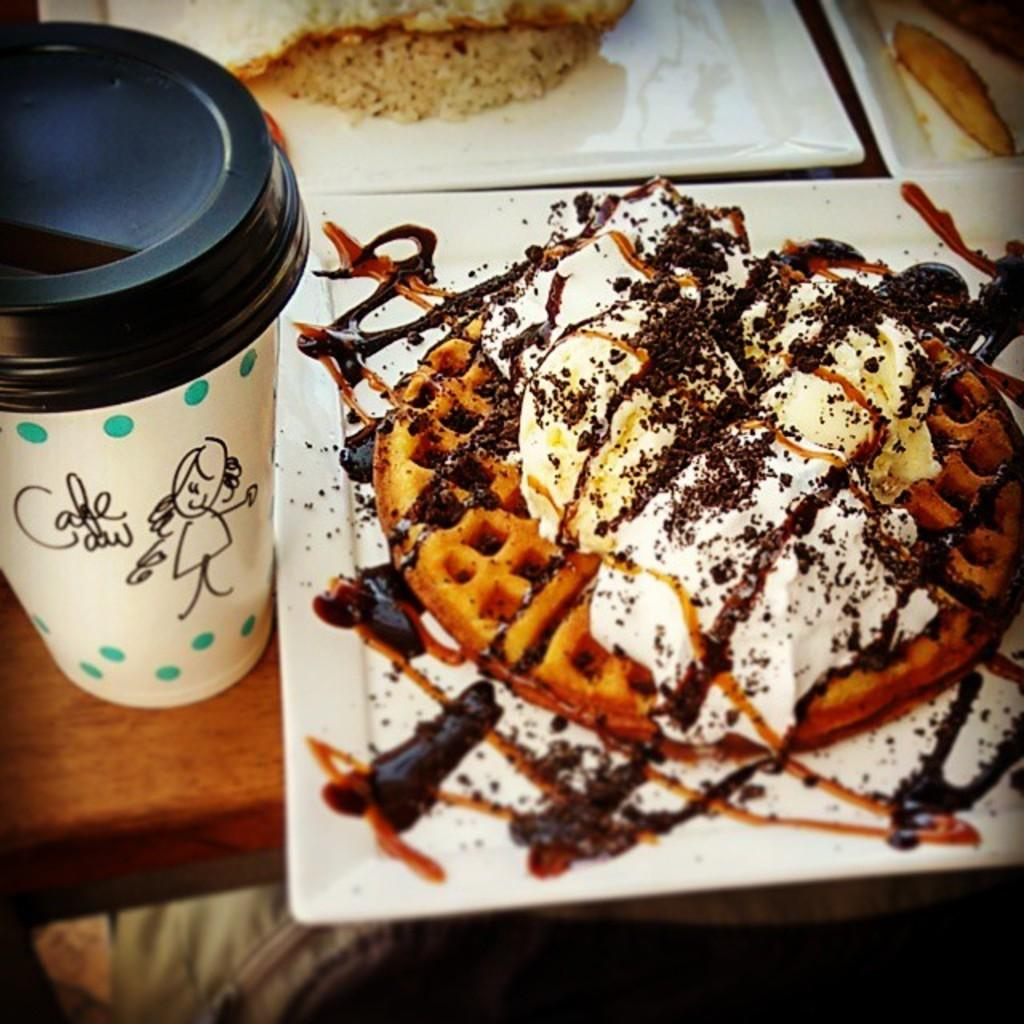What type of items are present on the plates in the image? The eatables are placed on white plates in the image. Can you describe the appearance of the plates? The plates are white in the image. What else can be seen in the left corner of the image? There is a shake bottle in the left corner of the image. Reasoning: Let't: Let's think step by step in order to produce the conversation. We start by identifying the main subject in the image, which is the eatables on the plates. Then, we expand the conversation to include the color and material of the plates. Finally, we mention the additional item present in the image, which is the shake bottle in the left corner. Each question is designed to elicit a specific detail about the image that is known from the provided facts. Absurd Question/Answer: What type of zinc can be seen in the image? There is no zinc present in the image. What is being offered to the person in the image? The image does not depict a person or any offering. 